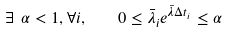<formula> <loc_0><loc_0><loc_500><loc_500>\exists \ \alpha < 1 , \forall i , \quad 0 \leq \bar { \lambda } _ { i } e ^ { \bar { \lambda } \Delta t _ { i } } \leq \alpha</formula> 